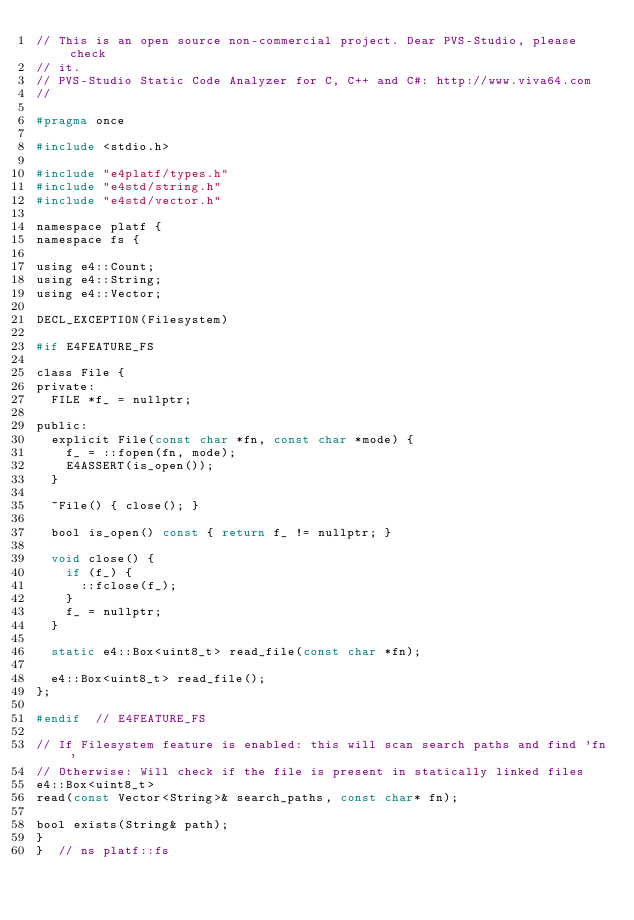Convert code to text. <code><loc_0><loc_0><loc_500><loc_500><_C_>// This is an open source non-commercial project. Dear PVS-Studio, please check
// it.
// PVS-Studio Static Code Analyzer for C, C++ and C#: http://www.viva64.com
//

#pragma once

#include <stdio.h>

#include "e4platf/types.h"
#include "e4std/string.h"
#include "e4std/vector.h"

namespace platf {
namespace fs {

using e4::Count;
using e4::String;
using e4::Vector;

DECL_EXCEPTION(Filesystem)

#if E4FEATURE_FS

class File {
private:
  FILE *f_ = nullptr;

public:
  explicit File(const char *fn, const char *mode) {
    f_ = ::fopen(fn, mode);
    E4ASSERT(is_open());
  }

  ~File() { close(); }

  bool is_open() const { return f_ != nullptr; }

  void close() {
    if (f_) {
      ::fclose(f_);
    }
    f_ = nullptr;
  }

  static e4::Box<uint8_t> read_file(const char *fn);

  e4::Box<uint8_t> read_file();
};

#endif  // E4FEATURE_FS

// If Filesystem feature is enabled: this will scan search paths and find 'fn'
// Otherwise: Will check if the file is present in statically linked files
e4::Box<uint8_t>
read(const Vector<String>& search_paths, const char* fn);

bool exists(String& path);
}
}  // ns platf::fs
</code> 